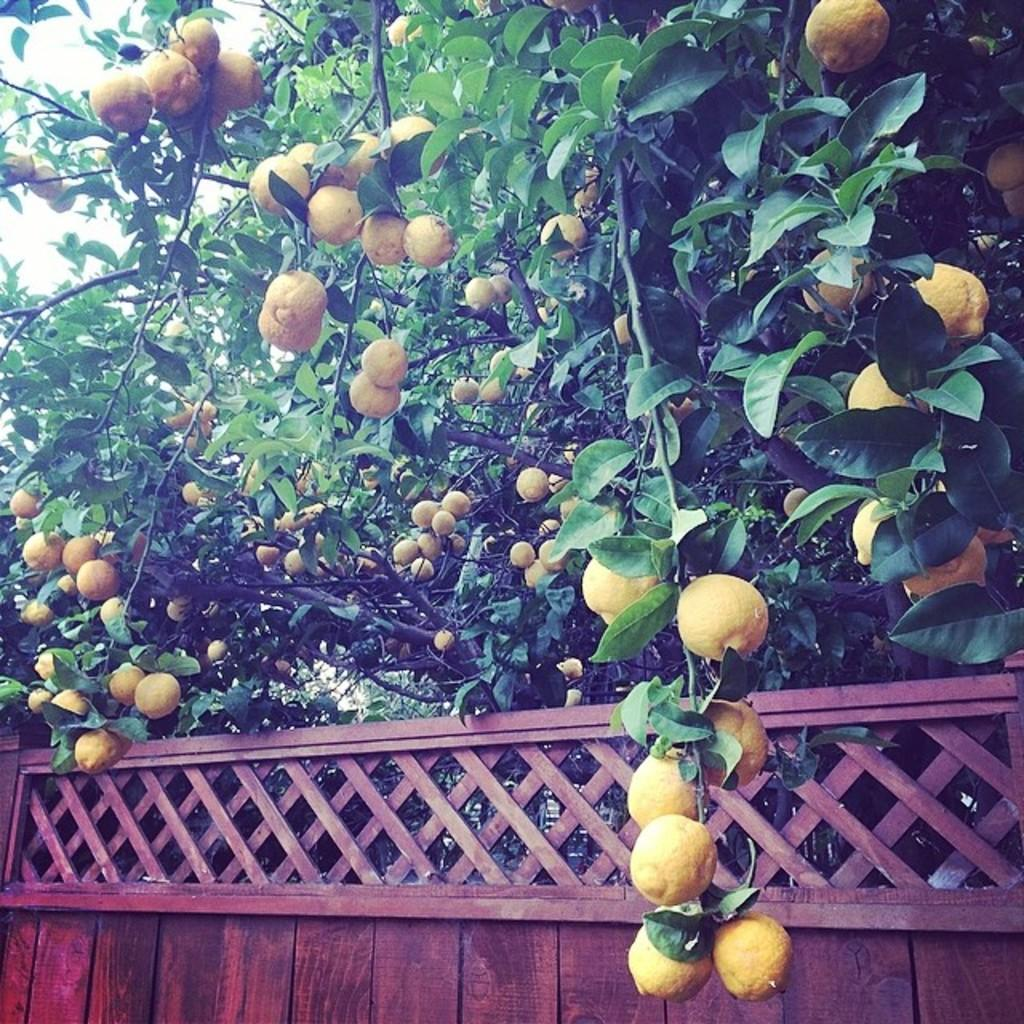What type of food items can be seen in the image? There are fruits in the image. What natural elements are present in the image? There are trees in the image. What architectural feature is visible at the bottom of the image? There is a wall at the bottom of the image. What can be seen in the distance in the image? The sky is visible in the background of the image. What type of test is being conducted in the image? There is no test being conducted in the image; it features fruits, trees, a wall, and the sky. 